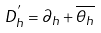<formula> <loc_0><loc_0><loc_500><loc_500>D _ { h } ^ { ^ { \prime } } = \partial _ { h } + \overline { \theta _ { h } }</formula> 